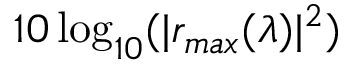<formula> <loc_0><loc_0><loc_500><loc_500>1 0 \log _ { 1 0 } ( | r _ { \max } ( \lambda ) | ^ { 2 } )</formula> 